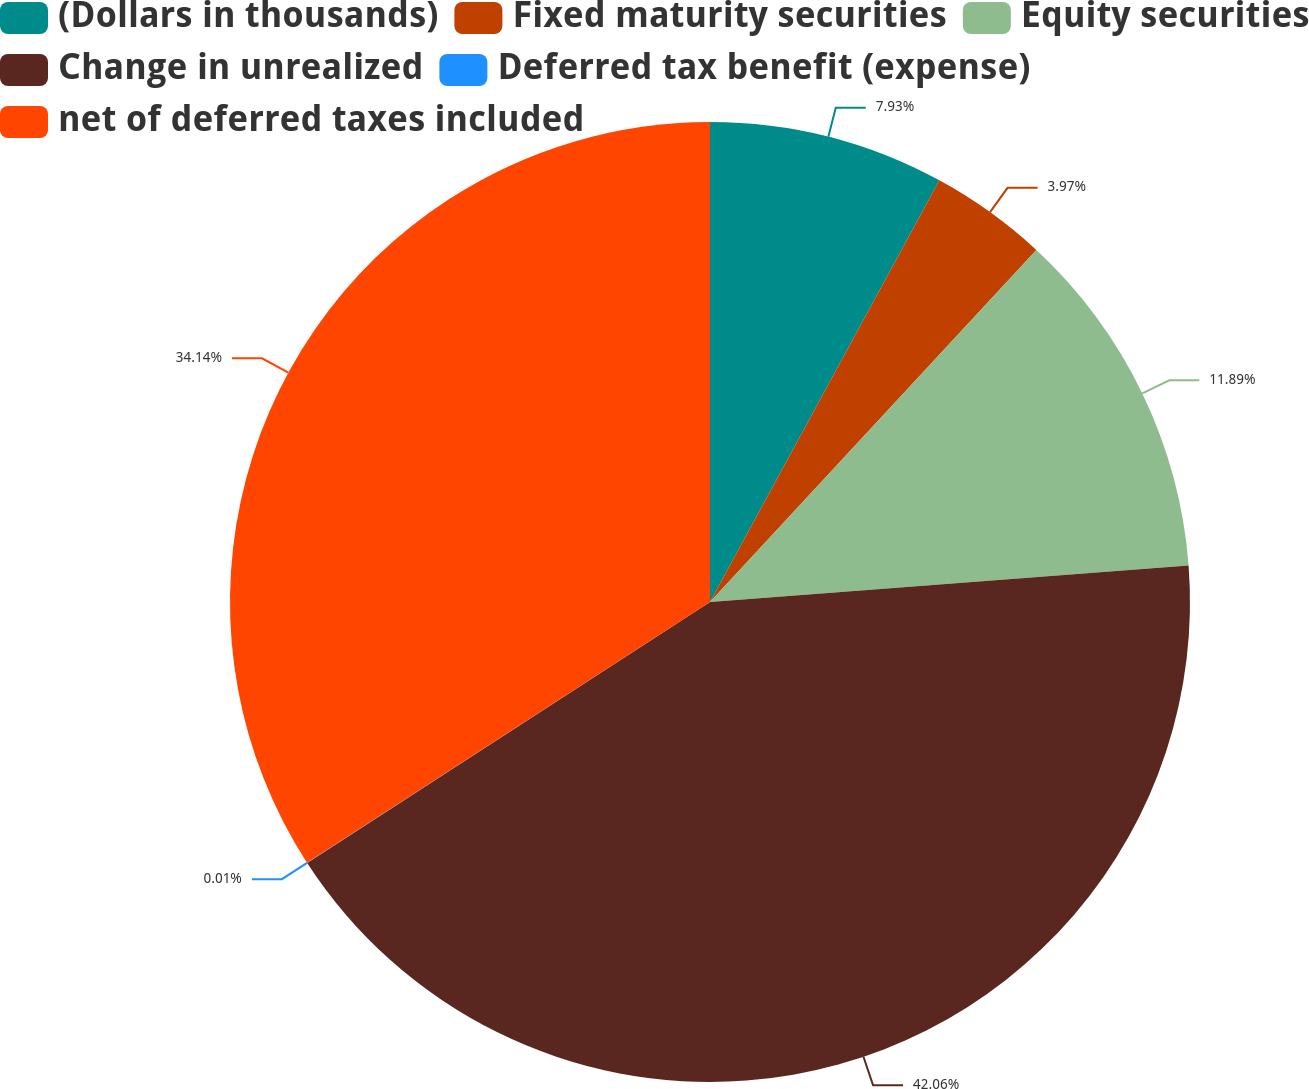<chart> <loc_0><loc_0><loc_500><loc_500><pie_chart><fcel>(Dollars in thousands)<fcel>Fixed maturity securities<fcel>Equity securities<fcel>Change in unrealized<fcel>Deferred tax benefit (expense)<fcel>net of deferred taxes included<nl><fcel>7.93%<fcel>3.97%<fcel>11.89%<fcel>42.06%<fcel>0.01%<fcel>34.14%<nl></chart> 